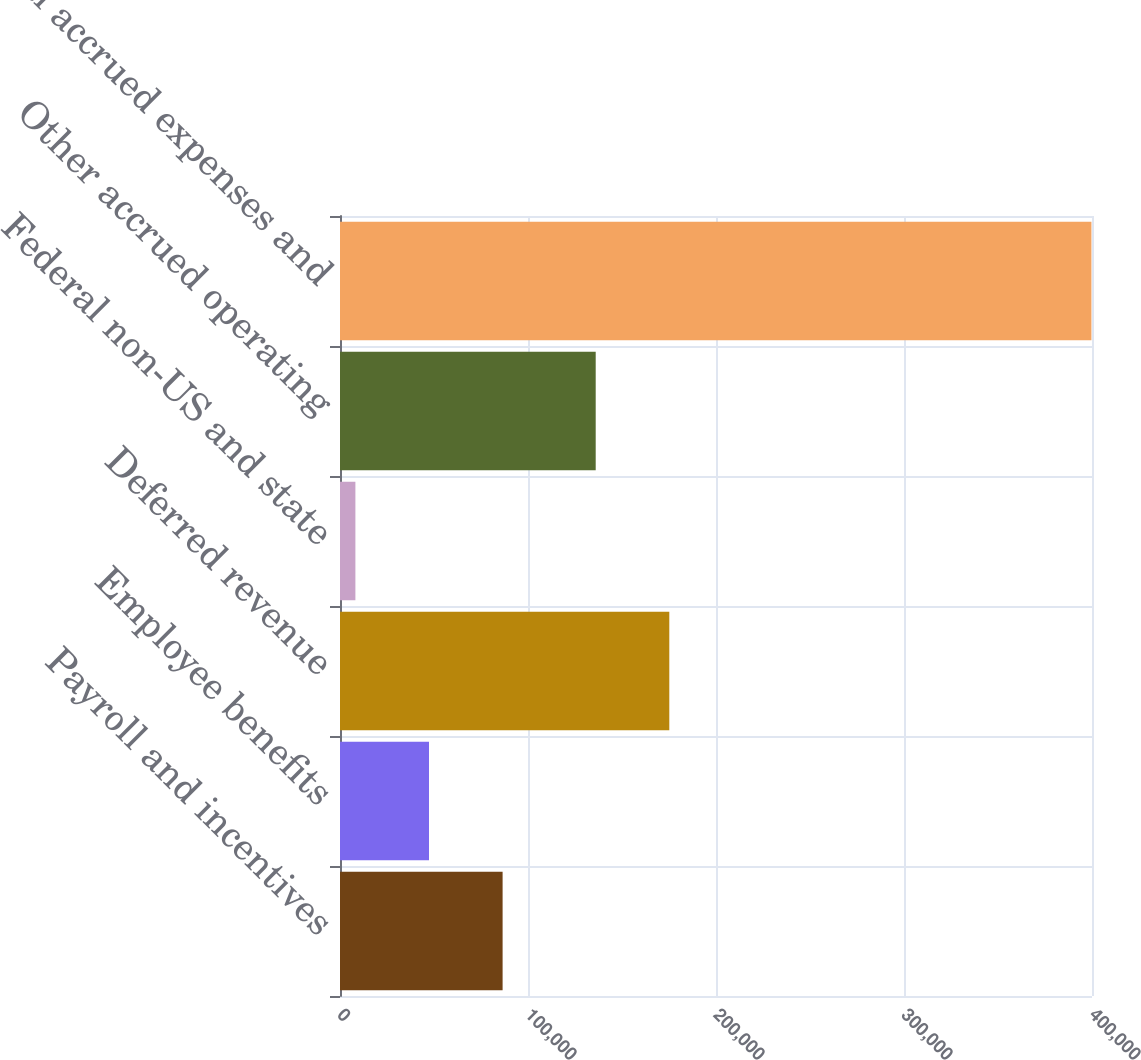Convert chart to OTSL. <chart><loc_0><loc_0><loc_500><loc_500><bar_chart><fcel>Payroll and incentives<fcel>Employee benefits<fcel>Deferred revenue<fcel>Federal non-US and state<fcel>Other accrued operating<fcel>Total accrued expenses and<nl><fcel>86491.2<fcel>47340.1<fcel>175162<fcel>8189<fcel>136011<fcel>399700<nl></chart> 